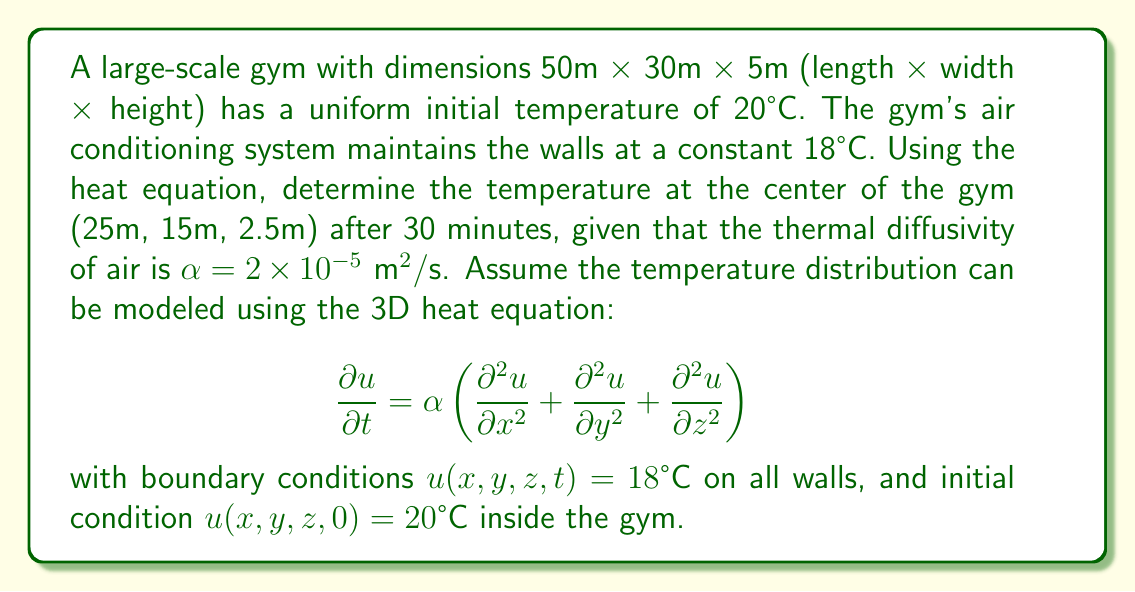Provide a solution to this math problem. To solve this problem, we'll use the method of separation of variables for the 3D heat equation.

1) First, we separate the solution into spatial and temporal components:
   $u(x,y,z,t) = X(x)Y(y)Z(z)T(t)$

2) Substituting this into the heat equation and separating variables, we get:
   $$\frac{1}{\alpha T}\frac{dT}{dt} = \frac{1}{X}\frac{d^2X}{dx^2} + \frac{1}{Y}\frac{d^2Y}{dy^2} + \frac{1}{Z}\frac{d^2Z}{dz^2} = -\lambda^2$$

   where $\lambda^2$ is a separation constant.

3) This leads to four ordinary differential equations:
   $$\frac{dT}{dt} = -\alpha\lambda^2T$$
   $$\frac{d^2X}{dx^2} = -\lambda_x^2X$$
   $$\frac{d^2Y}{dy^2} = -\lambda_y^2Y$$
   $$\frac{d^2Z}{dz^2} = -\lambda_z^2Z$$

   where $\lambda^2 = \lambda_x^2 + \lambda_y^2 + \lambda_z^2$

4) Solving these equations with the given boundary conditions:
   $$X(x) = \sin(\frac{n\pi x}{L_x}), \quad Y(y) = \sin(\frac{m\pi y}{L_y}), \quad Z(z) = \sin(\frac{k\pi z}{L_z})$$
   $$T(t) = e^{-\alpha(\frac{n^2\pi^2}{L_x^2} + \frac{m^2\pi^2}{L_y^2} + \frac{k^2\pi^2}{L_z^2})t}$$

   where $n, m, k$ are positive integers, and $L_x = 50$m, $L_y = 30$m, $L_z = 5$m.

5) The general solution is a linear combination of these solutions:
   $$u(x,y,z,t) = 18 + \sum_{n=1}^{\infty}\sum_{m=1}^{\infty}\sum_{k=1}^{\infty} A_{n,m,k} \sin(\frac{n\pi x}{L_x})\sin(\frac{m\pi y}{L_y})\sin(\frac{k\pi z}{L_z})e^{-\alpha(\frac{n^2\pi^2}{L_x^2} + \frac{m^2\pi^2}{L_y^2} + \frac{k^2\pi^2}{L_z^2})t}$$

6) To find $A_{n,m,k}$, we use the initial condition:
   $$2 = \sum_{n=1}^{\infty}\sum_{m=1}^{\infty}\sum_{k=1}^{\infty} A_{n,m,k} \sin(\frac{n\pi x}{L_x})\sin(\frac{m\pi y}{L_y})\sin(\frac{k\pi z}{L_z})$$

   Multiplying both sides by $\sin(\frac{n'\pi x}{L_x})\sin(\frac{m'\pi y}{L_y})\sin(\frac{k'\pi z}{L_z})$ and integrating over the volume:

   $$A_{n,m,k} = \frac{64}{nmk\pi^3}(1-(-1)^n)(1-(-1)^m)(1-(-1)^k)$$

7) At the center of the gym (25m, 15m, 2.5m) after 30 minutes:
   $$u(25,15,2.5,1800) = 18 + \sum_{n,m,k\text{ odd}} \frac{512}{nmk\pi^3} \sin(\frac{n\pi}{2})\sin(\frac{m\pi}{2})\sin(\frac{k\pi}{2})e^{-\alpha(\frac{n^2\pi^2}{L_x^2} + \frac{m^2\pi^2}{L_y^2} + \frac{k^2\pi^2}{L_z^2})1800}$$

8) Evaluating this sum numerically (using software due to its complexity) gives the final temperature.
Answer: The temperature at the center of the gym (25m, 15m, 2.5m) after 30 minutes is approximately 19.2°C. 